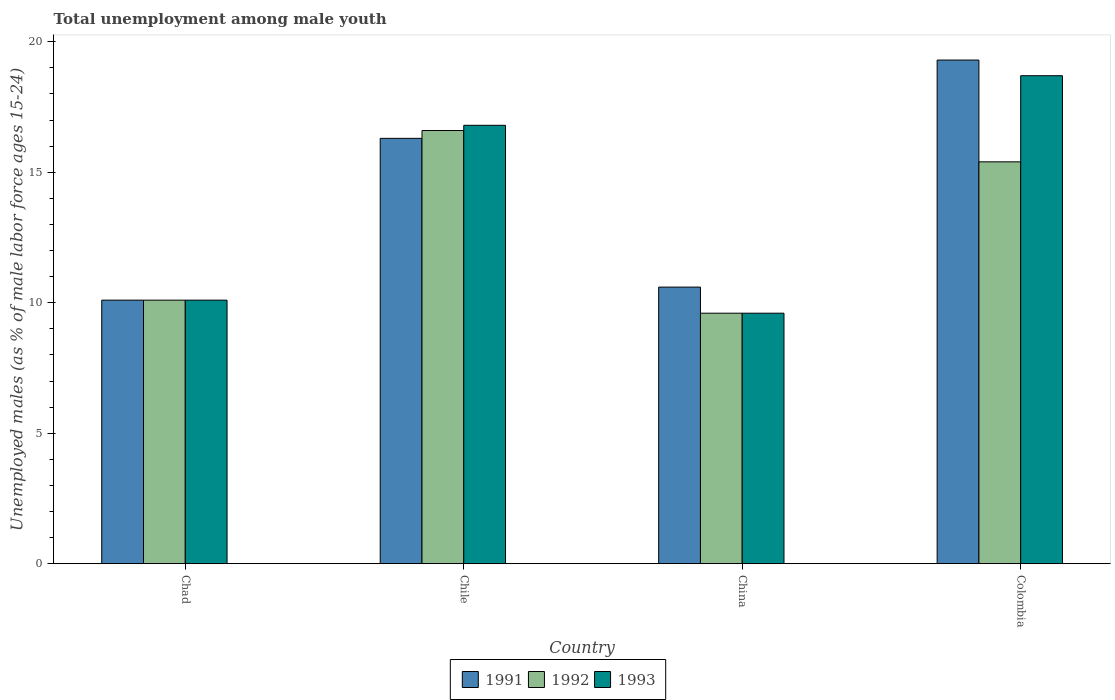How many different coloured bars are there?
Keep it short and to the point. 3. Are the number of bars per tick equal to the number of legend labels?
Provide a short and direct response. Yes. Are the number of bars on each tick of the X-axis equal?
Provide a short and direct response. Yes. How many bars are there on the 1st tick from the right?
Give a very brief answer. 3. What is the label of the 2nd group of bars from the left?
Provide a succinct answer. Chile. What is the percentage of unemployed males in in 1991 in China?
Provide a succinct answer. 10.6. Across all countries, what is the maximum percentage of unemployed males in in 1991?
Offer a very short reply. 19.3. Across all countries, what is the minimum percentage of unemployed males in in 1991?
Ensure brevity in your answer.  10.1. What is the total percentage of unemployed males in in 1991 in the graph?
Provide a succinct answer. 56.3. What is the difference between the percentage of unemployed males in in 1991 in Colombia and the percentage of unemployed males in in 1992 in China?
Make the answer very short. 9.7. What is the average percentage of unemployed males in in 1991 per country?
Offer a terse response. 14.07. What is the difference between the percentage of unemployed males in of/in 1993 and percentage of unemployed males in of/in 1992 in Chile?
Offer a very short reply. 0.2. What is the ratio of the percentage of unemployed males in in 1991 in Chad to that in Chile?
Provide a short and direct response. 0.62. What is the difference between the highest and the second highest percentage of unemployed males in in 1992?
Offer a terse response. 6.5. What is the difference between the highest and the lowest percentage of unemployed males in in 1992?
Give a very brief answer. 7. What does the 1st bar from the left in Chile represents?
Ensure brevity in your answer.  1991. Is it the case that in every country, the sum of the percentage of unemployed males in in 1991 and percentage of unemployed males in in 1992 is greater than the percentage of unemployed males in in 1993?
Make the answer very short. Yes. Are all the bars in the graph horizontal?
Your answer should be compact. No. Are the values on the major ticks of Y-axis written in scientific E-notation?
Keep it short and to the point. No. What is the title of the graph?
Provide a short and direct response. Total unemployment among male youth. What is the label or title of the X-axis?
Offer a very short reply. Country. What is the label or title of the Y-axis?
Your response must be concise. Unemployed males (as % of male labor force ages 15-24). What is the Unemployed males (as % of male labor force ages 15-24) of 1991 in Chad?
Offer a terse response. 10.1. What is the Unemployed males (as % of male labor force ages 15-24) in 1992 in Chad?
Make the answer very short. 10.1. What is the Unemployed males (as % of male labor force ages 15-24) in 1993 in Chad?
Offer a terse response. 10.1. What is the Unemployed males (as % of male labor force ages 15-24) of 1991 in Chile?
Your response must be concise. 16.3. What is the Unemployed males (as % of male labor force ages 15-24) of 1992 in Chile?
Your answer should be very brief. 16.6. What is the Unemployed males (as % of male labor force ages 15-24) of 1993 in Chile?
Make the answer very short. 16.8. What is the Unemployed males (as % of male labor force ages 15-24) of 1991 in China?
Your answer should be compact. 10.6. What is the Unemployed males (as % of male labor force ages 15-24) in 1992 in China?
Ensure brevity in your answer.  9.6. What is the Unemployed males (as % of male labor force ages 15-24) in 1993 in China?
Ensure brevity in your answer.  9.6. What is the Unemployed males (as % of male labor force ages 15-24) of 1991 in Colombia?
Ensure brevity in your answer.  19.3. What is the Unemployed males (as % of male labor force ages 15-24) in 1992 in Colombia?
Provide a short and direct response. 15.4. What is the Unemployed males (as % of male labor force ages 15-24) in 1993 in Colombia?
Your response must be concise. 18.7. Across all countries, what is the maximum Unemployed males (as % of male labor force ages 15-24) in 1991?
Your response must be concise. 19.3. Across all countries, what is the maximum Unemployed males (as % of male labor force ages 15-24) of 1992?
Give a very brief answer. 16.6. Across all countries, what is the maximum Unemployed males (as % of male labor force ages 15-24) of 1993?
Keep it short and to the point. 18.7. Across all countries, what is the minimum Unemployed males (as % of male labor force ages 15-24) in 1991?
Your response must be concise. 10.1. Across all countries, what is the minimum Unemployed males (as % of male labor force ages 15-24) in 1992?
Your answer should be very brief. 9.6. Across all countries, what is the minimum Unemployed males (as % of male labor force ages 15-24) of 1993?
Your answer should be compact. 9.6. What is the total Unemployed males (as % of male labor force ages 15-24) of 1991 in the graph?
Your answer should be very brief. 56.3. What is the total Unemployed males (as % of male labor force ages 15-24) of 1992 in the graph?
Ensure brevity in your answer.  51.7. What is the total Unemployed males (as % of male labor force ages 15-24) in 1993 in the graph?
Offer a terse response. 55.2. What is the difference between the Unemployed males (as % of male labor force ages 15-24) in 1991 in Chad and that in China?
Provide a succinct answer. -0.5. What is the difference between the Unemployed males (as % of male labor force ages 15-24) of 1993 in Chad and that in Colombia?
Ensure brevity in your answer.  -8.6. What is the difference between the Unemployed males (as % of male labor force ages 15-24) in 1992 in Chile and that in China?
Provide a succinct answer. 7. What is the difference between the Unemployed males (as % of male labor force ages 15-24) in 1993 in Chile and that in China?
Give a very brief answer. 7.2. What is the difference between the Unemployed males (as % of male labor force ages 15-24) in 1992 in Chile and that in Colombia?
Provide a succinct answer. 1.2. What is the difference between the Unemployed males (as % of male labor force ages 15-24) of 1993 in Chile and that in Colombia?
Offer a terse response. -1.9. What is the difference between the Unemployed males (as % of male labor force ages 15-24) of 1992 in China and that in Colombia?
Offer a terse response. -5.8. What is the difference between the Unemployed males (as % of male labor force ages 15-24) of 1993 in China and that in Colombia?
Keep it short and to the point. -9.1. What is the difference between the Unemployed males (as % of male labor force ages 15-24) of 1992 in Chad and the Unemployed males (as % of male labor force ages 15-24) of 1993 in Chile?
Your response must be concise. -6.7. What is the difference between the Unemployed males (as % of male labor force ages 15-24) of 1991 in Chad and the Unemployed males (as % of male labor force ages 15-24) of 1992 in China?
Offer a terse response. 0.5. What is the difference between the Unemployed males (as % of male labor force ages 15-24) in 1992 in Chad and the Unemployed males (as % of male labor force ages 15-24) in 1993 in China?
Ensure brevity in your answer.  0.5. What is the difference between the Unemployed males (as % of male labor force ages 15-24) in 1991 in Chad and the Unemployed males (as % of male labor force ages 15-24) in 1992 in Colombia?
Ensure brevity in your answer.  -5.3. What is the difference between the Unemployed males (as % of male labor force ages 15-24) in 1992 in Chad and the Unemployed males (as % of male labor force ages 15-24) in 1993 in Colombia?
Make the answer very short. -8.6. What is the difference between the Unemployed males (as % of male labor force ages 15-24) in 1991 in Chile and the Unemployed males (as % of male labor force ages 15-24) in 1992 in China?
Keep it short and to the point. 6.7. What is the difference between the Unemployed males (as % of male labor force ages 15-24) in 1991 in Chile and the Unemployed males (as % of male labor force ages 15-24) in 1993 in China?
Offer a terse response. 6.7. What is the difference between the Unemployed males (as % of male labor force ages 15-24) in 1991 in Chile and the Unemployed males (as % of male labor force ages 15-24) in 1992 in Colombia?
Offer a terse response. 0.9. What is the difference between the Unemployed males (as % of male labor force ages 15-24) in 1992 in Chile and the Unemployed males (as % of male labor force ages 15-24) in 1993 in Colombia?
Provide a succinct answer. -2.1. What is the difference between the Unemployed males (as % of male labor force ages 15-24) in 1991 in China and the Unemployed males (as % of male labor force ages 15-24) in 1992 in Colombia?
Make the answer very short. -4.8. What is the average Unemployed males (as % of male labor force ages 15-24) of 1991 per country?
Make the answer very short. 14.07. What is the average Unemployed males (as % of male labor force ages 15-24) in 1992 per country?
Provide a succinct answer. 12.93. What is the difference between the Unemployed males (as % of male labor force ages 15-24) in 1992 and Unemployed males (as % of male labor force ages 15-24) in 1993 in Chad?
Keep it short and to the point. 0. What is the difference between the Unemployed males (as % of male labor force ages 15-24) of 1991 and Unemployed males (as % of male labor force ages 15-24) of 1992 in Chile?
Offer a very short reply. -0.3. What is the difference between the Unemployed males (as % of male labor force ages 15-24) of 1991 and Unemployed males (as % of male labor force ages 15-24) of 1993 in Chile?
Offer a very short reply. -0.5. What is the difference between the Unemployed males (as % of male labor force ages 15-24) in 1992 and Unemployed males (as % of male labor force ages 15-24) in 1993 in Chile?
Make the answer very short. -0.2. What is the difference between the Unemployed males (as % of male labor force ages 15-24) of 1991 and Unemployed males (as % of male labor force ages 15-24) of 1993 in China?
Ensure brevity in your answer.  1. What is the difference between the Unemployed males (as % of male labor force ages 15-24) of 1992 and Unemployed males (as % of male labor force ages 15-24) of 1993 in Colombia?
Your response must be concise. -3.3. What is the ratio of the Unemployed males (as % of male labor force ages 15-24) of 1991 in Chad to that in Chile?
Offer a terse response. 0.62. What is the ratio of the Unemployed males (as % of male labor force ages 15-24) of 1992 in Chad to that in Chile?
Your answer should be very brief. 0.61. What is the ratio of the Unemployed males (as % of male labor force ages 15-24) in 1993 in Chad to that in Chile?
Offer a terse response. 0.6. What is the ratio of the Unemployed males (as % of male labor force ages 15-24) in 1991 in Chad to that in China?
Make the answer very short. 0.95. What is the ratio of the Unemployed males (as % of male labor force ages 15-24) of 1992 in Chad to that in China?
Your answer should be compact. 1.05. What is the ratio of the Unemployed males (as % of male labor force ages 15-24) in 1993 in Chad to that in China?
Keep it short and to the point. 1.05. What is the ratio of the Unemployed males (as % of male labor force ages 15-24) in 1991 in Chad to that in Colombia?
Your response must be concise. 0.52. What is the ratio of the Unemployed males (as % of male labor force ages 15-24) of 1992 in Chad to that in Colombia?
Your answer should be compact. 0.66. What is the ratio of the Unemployed males (as % of male labor force ages 15-24) of 1993 in Chad to that in Colombia?
Ensure brevity in your answer.  0.54. What is the ratio of the Unemployed males (as % of male labor force ages 15-24) of 1991 in Chile to that in China?
Your response must be concise. 1.54. What is the ratio of the Unemployed males (as % of male labor force ages 15-24) of 1992 in Chile to that in China?
Provide a short and direct response. 1.73. What is the ratio of the Unemployed males (as % of male labor force ages 15-24) in 1991 in Chile to that in Colombia?
Keep it short and to the point. 0.84. What is the ratio of the Unemployed males (as % of male labor force ages 15-24) of 1992 in Chile to that in Colombia?
Provide a succinct answer. 1.08. What is the ratio of the Unemployed males (as % of male labor force ages 15-24) in 1993 in Chile to that in Colombia?
Offer a very short reply. 0.9. What is the ratio of the Unemployed males (as % of male labor force ages 15-24) of 1991 in China to that in Colombia?
Offer a very short reply. 0.55. What is the ratio of the Unemployed males (as % of male labor force ages 15-24) of 1992 in China to that in Colombia?
Keep it short and to the point. 0.62. What is the ratio of the Unemployed males (as % of male labor force ages 15-24) in 1993 in China to that in Colombia?
Provide a short and direct response. 0.51. What is the difference between the highest and the second highest Unemployed males (as % of male labor force ages 15-24) of 1991?
Offer a very short reply. 3. What is the difference between the highest and the second highest Unemployed males (as % of male labor force ages 15-24) of 1993?
Offer a terse response. 1.9. What is the difference between the highest and the lowest Unemployed males (as % of male labor force ages 15-24) in 1992?
Your response must be concise. 7. 